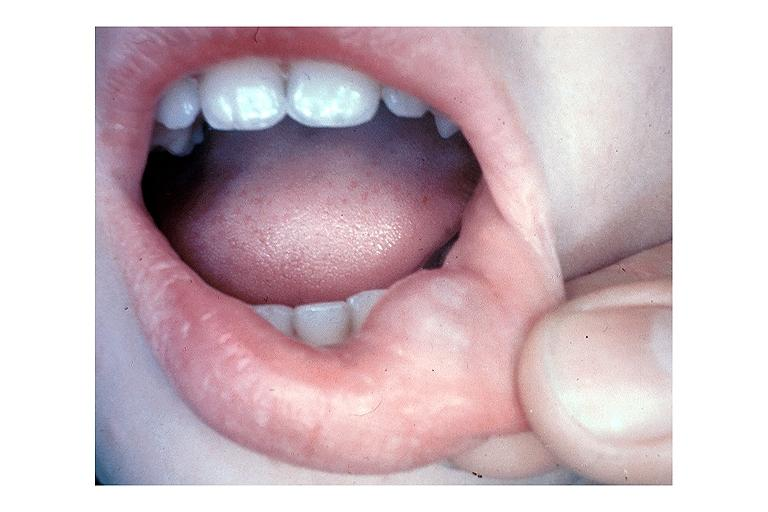where is this?
Answer the question using a single word or phrase. Oral 